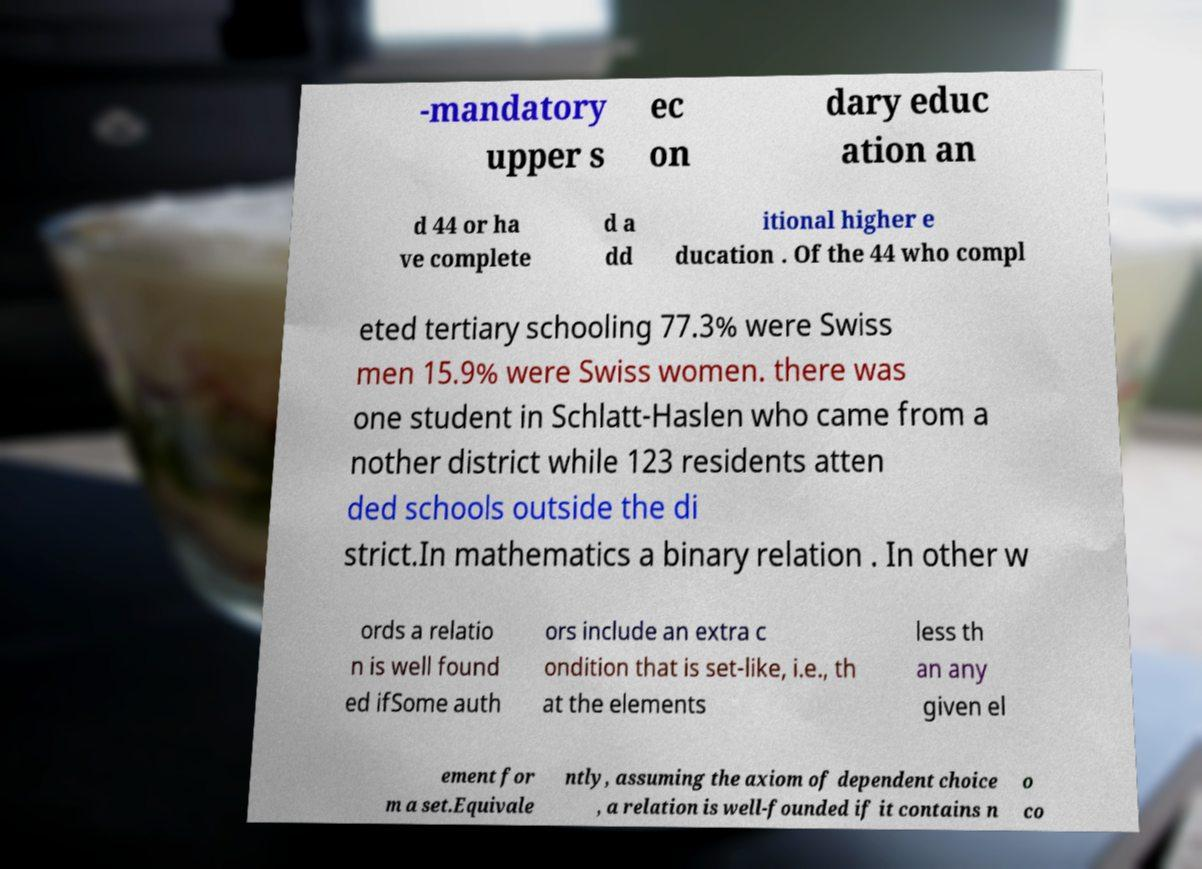Can you read and provide the text displayed in the image?This photo seems to have some interesting text. Can you extract and type it out for me? -mandatory upper s ec on dary educ ation an d 44 or ha ve complete d a dd itional higher e ducation . Of the 44 who compl eted tertiary schooling 77.3% were Swiss men 15.9% were Swiss women. there was one student in Schlatt-Haslen who came from a nother district while 123 residents atten ded schools outside the di strict.In mathematics a binary relation . In other w ords a relatio n is well found ed ifSome auth ors include an extra c ondition that is set-like, i.e., th at the elements less th an any given el ement for m a set.Equivale ntly, assuming the axiom of dependent choice , a relation is well-founded if it contains n o co 